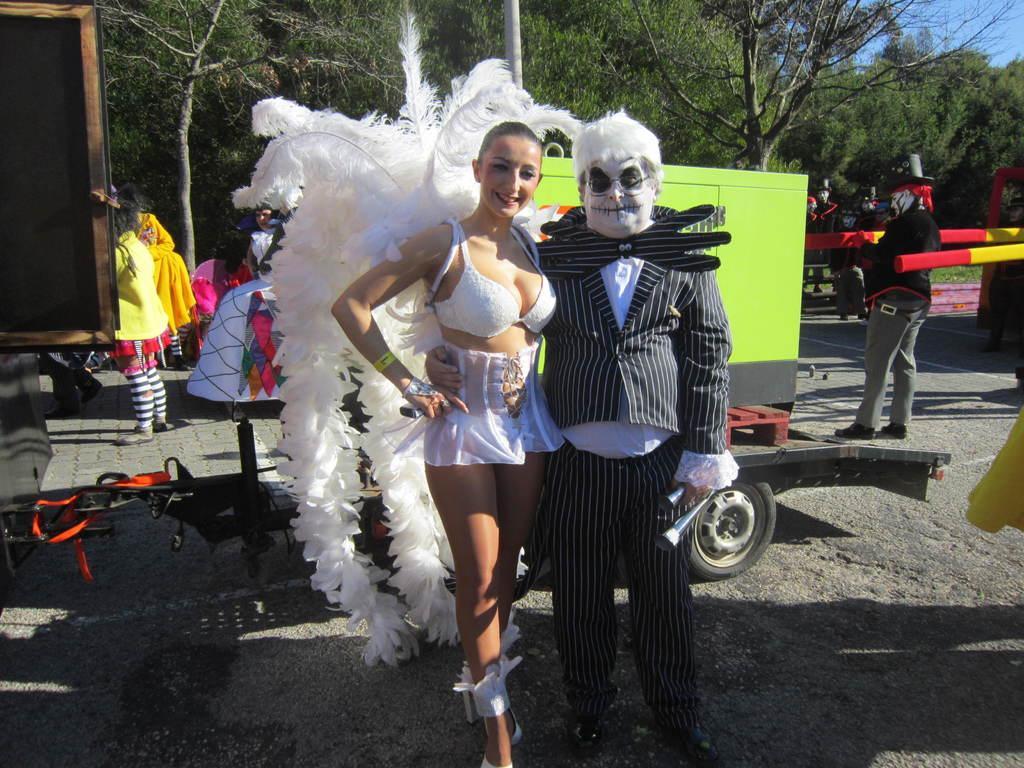Please provide a concise description of this image. In this picture there is a man and a woman in the center of the image, they are wearing costumes and there are other people, vehicles and trees in the background area of the image. 